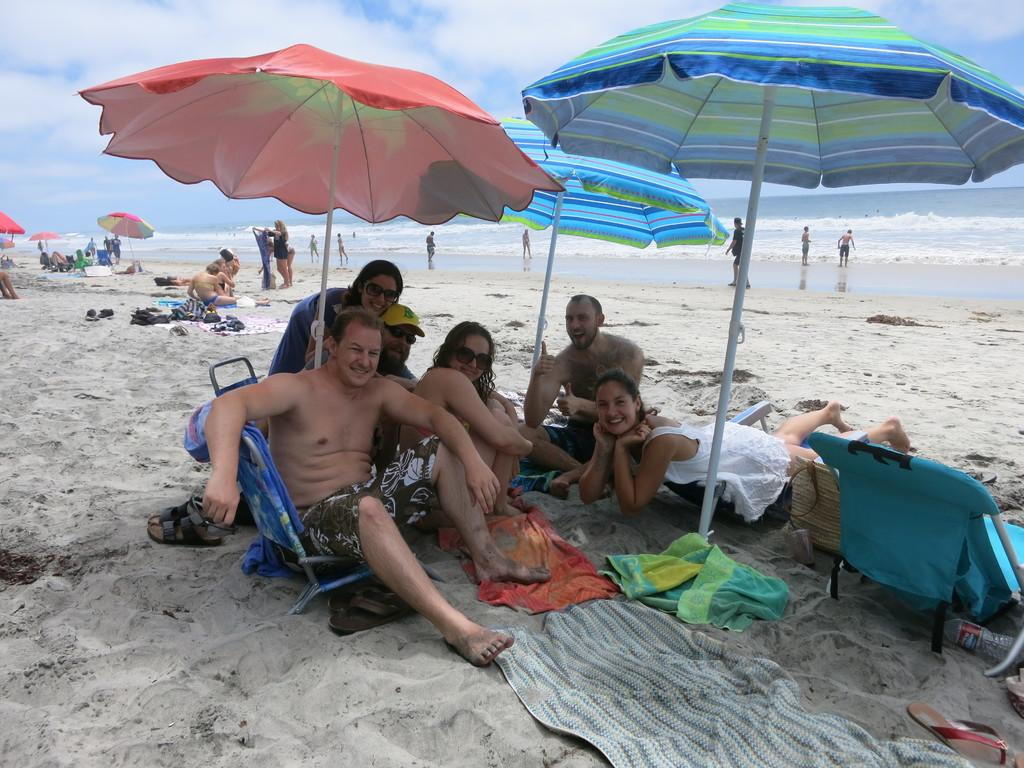What type of location is shown in the image? The image depicts a beach. What objects can be seen on the beach? There are umbrellas in the image. What are some people doing in the image? Some persons are sitting and some are standing in the image. What natural feature is visible in the image? Waves are visible in the image. Where is the road leading to the beach in the image? There is no road visible in the image; it depicts a beach setting without any roads. What type of animal is playing with a cub in the image? There are no animals or cubs present in the image; it features a beach scene with people and umbrellas. 